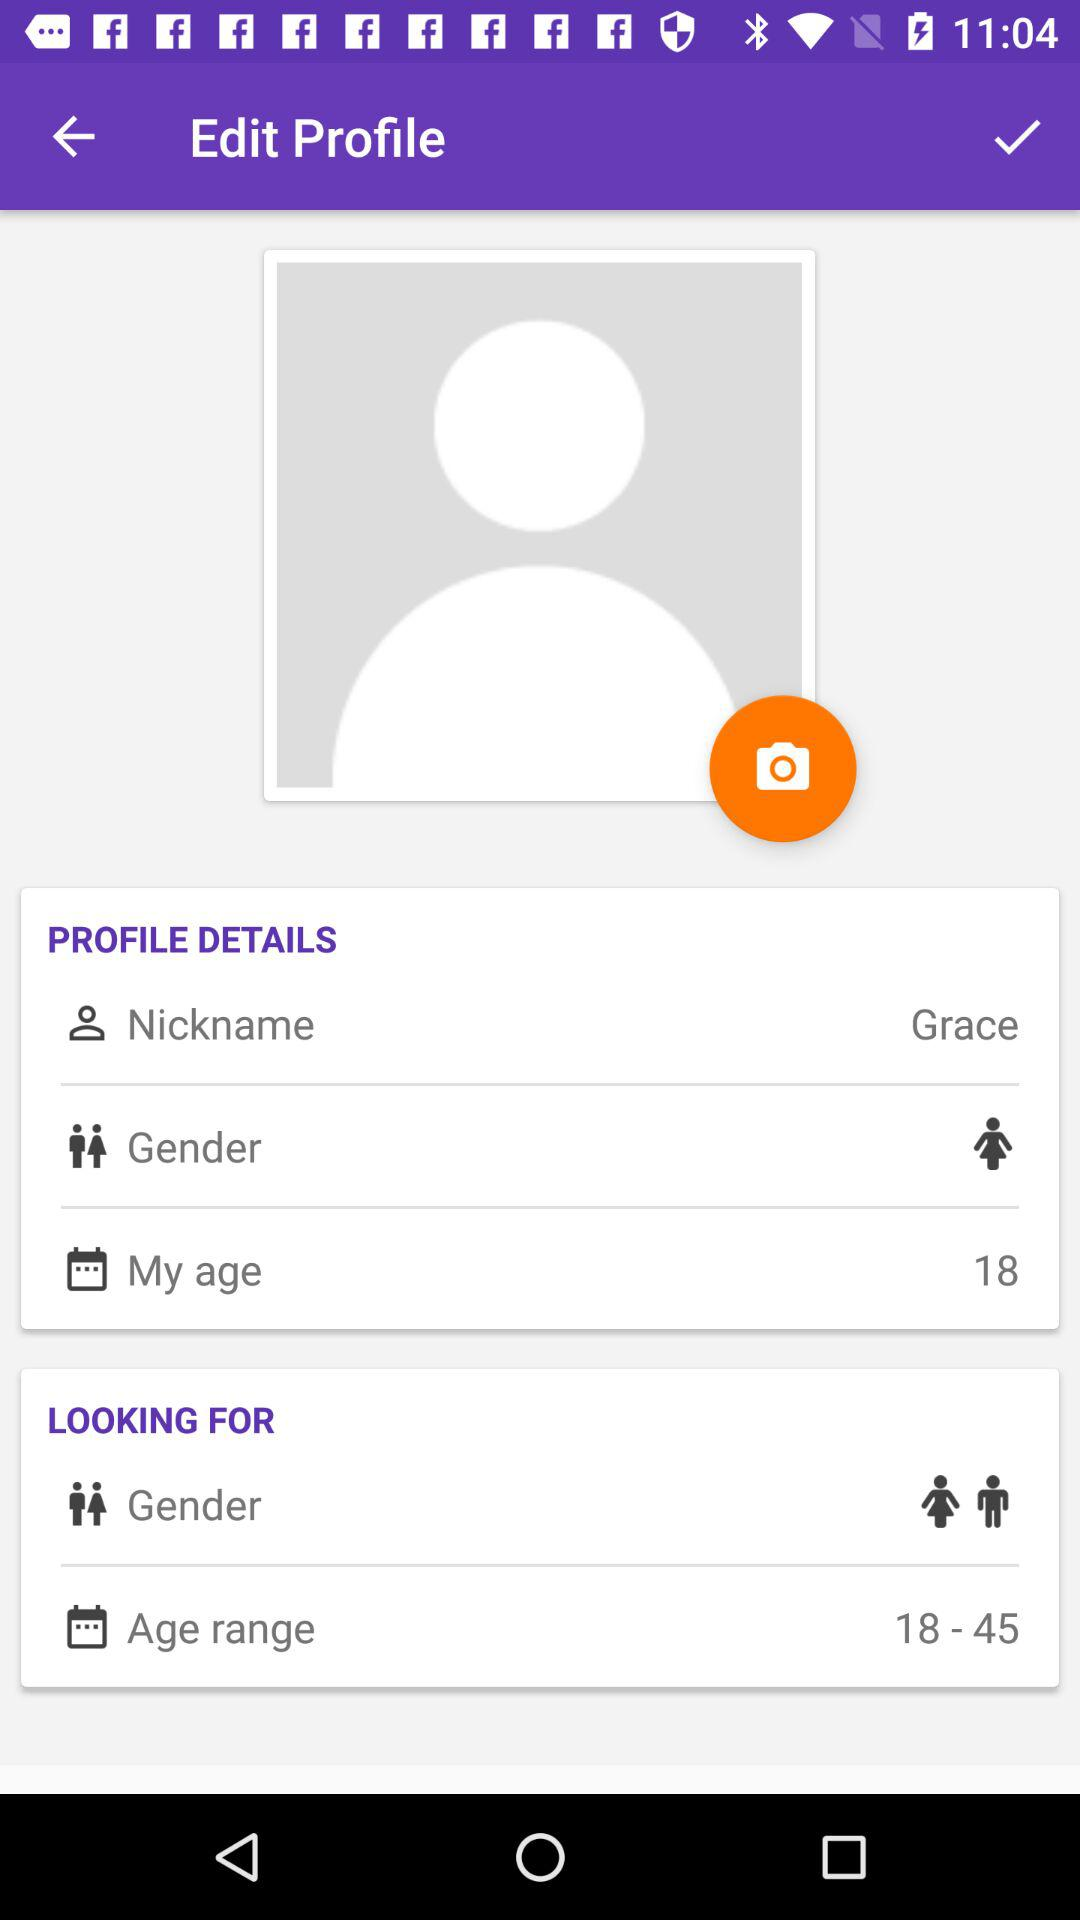What is the age? The age is 18 years. 